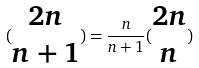Convert formula to latex. <formula><loc_0><loc_0><loc_500><loc_500>( \begin{matrix} 2 n \\ n + 1 \end{matrix} ) = \frac { n } { n + 1 } ( \begin{matrix} 2 n \\ n \end{matrix} )</formula> 